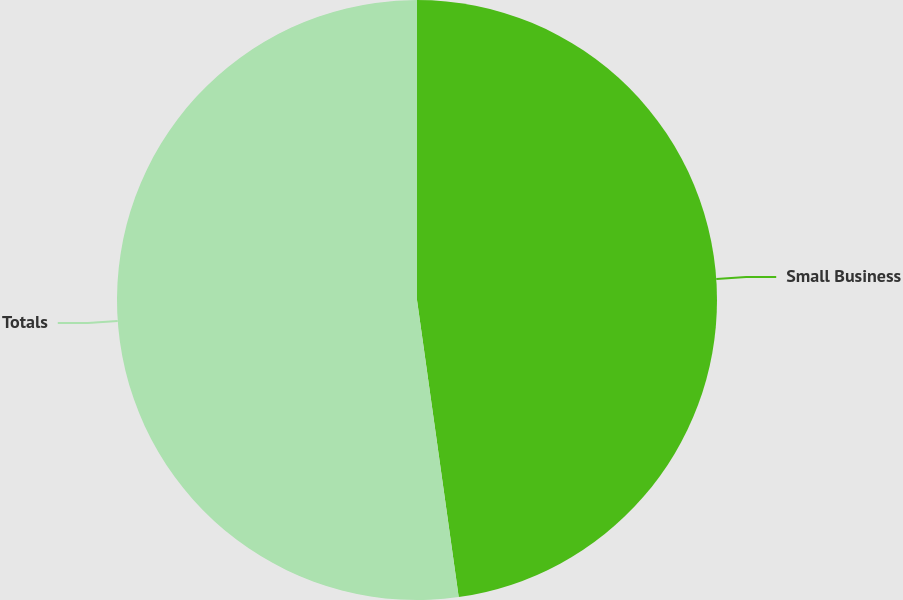<chart> <loc_0><loc_0><loc_500><loc_500><pie_chart><fcel>Small Business<fcel>Totals<nl><fcel>47.78%<fcel>52.22%<nl></chart> 